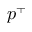Convert formula to latex. <formula><loc_0><loc_0><loc_500><loc_500>p ^ { + }</formula> 